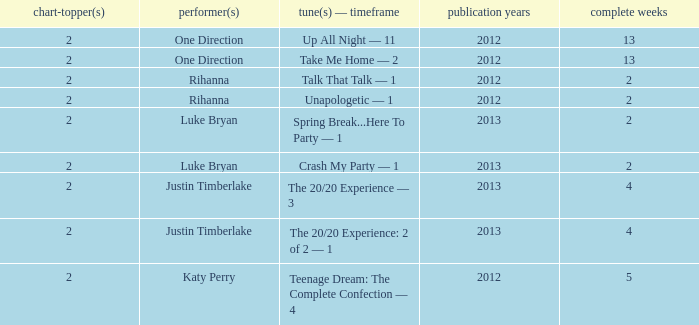Write the full table. {'header': ['chart-topper(s)', 'performer(s)', 'tune(s) — timeframe', 'publication years', 'complete weeks'], 'rows': [['2', 'One Direction', 'Up All Night — 11', '2012', '13'], ['2', 'One Direction', 'Take Me Home — 2', '2012', '13'], ['2', 'Rihanna', 'Talk That Talk — 1', '2012', '2'], ['2', 'Rihanna', 'Unapologetic — 1', '2012', '2'], ['2', 'Luke Bryan', 'Spring Break...Here To Party — 1', '2013', '2'], ['2', 'Luke Bryan', 'Crash My Party — 1', '2013', '2'], ['2', 'Justin Timberlake', 'The 20/20 Experience — 3', '2013', '4'], ['2', 'Justin Timberlake', 'The 20/20 Experience: 2 of 2 — 1', '2013', '4'], ['2', 'Katy Perry', 'Teenage Dream: The Complete Confection — 4', '2012', '5']]} What is the title of every song, and how many weeks was each song at #1 for Rihanna in 2012? Talk That Talk — 1, Unapologetic — 1. 